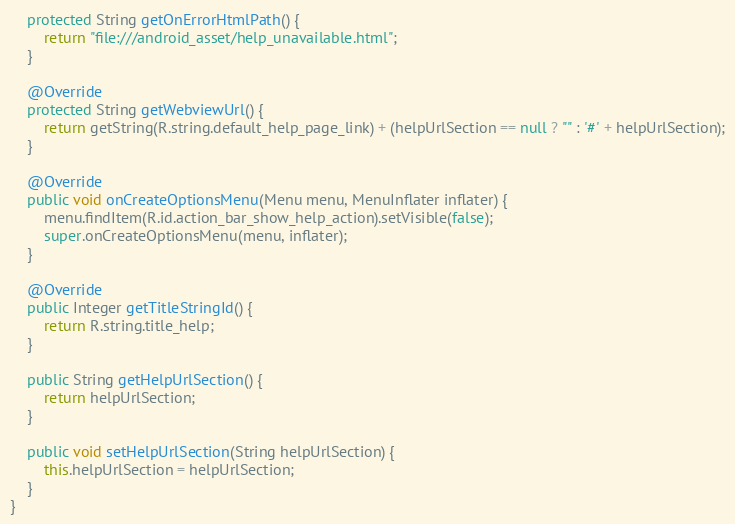Convert code to text. <code><loc_0><loc_0><loc_500><loc_500><_Java_>    protected String getOnErrorHtmlPath() {
        return "file:///android_asset/help_unavailable.html";
    }

    @Override
    protected String getWebviewUrl() {
        return getString(R.string.default_help_page_link) + (helpUrlSection == null ? "" : '#' + helpUrlSection);
    }

    @Override
    public void onCreateOptionsMenu(Menu menu, MenuInflater inflater) {
        menu.findItem(R.id.action_bar_show_help_action).setVisible(false);
        super.onCreateOptionsMenu(menu, inflater);
    }

    @Override
    public Integer getTitleStringId() {
        return R.string.title_help;
    }

    public String getHelpUrlSection() {
        return helpUrlSection;
    }

    public void setHelpUrlSection(String helpUrlSection) {
        this.helpUrlSection = helpUrlSection;
    }
}
</code> 